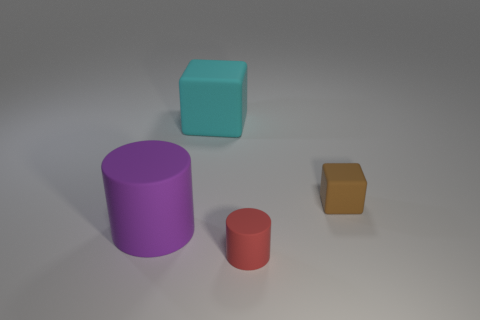There is a large rubber thing in front of the block on the left side of the cylinder right of the large purple cylinder; what is its shape?
Your response must be concise. Cylinder. Are there any matte blocks that have the same size as the purple cylinder?
Keep it short and to the point. Yes. How big is the red rubber thing?
Your response must be concise. Small. How many gray metallic blocks have the same size as the red cylinder?
Make the answer very short. 0. Are there fewer big things in front of the tiny red matte cylinder than small matte cubes in front of the large purple cylinder?
Your answer should be compact. No. There is a block that is left of the block on the right side of the tiny object in front of the large purple rubber cylinder; what size is it?
Give a very brief answer. Large. There is a object that is in front of the small brown rubber cube and behind the tiny red matte cylinder; what is its size?
Your answer should be compact. Large. There is a thing to the left of the block that is to the left of the small brown thing; what is its shape?
Give a very brief answer. Cylinder. Is there any other thing that has the same color as the large rubber cube?
Your answer should be very brief. No. The object right of the red matte object has what shape?
Provide a succinct answer. Cube. 